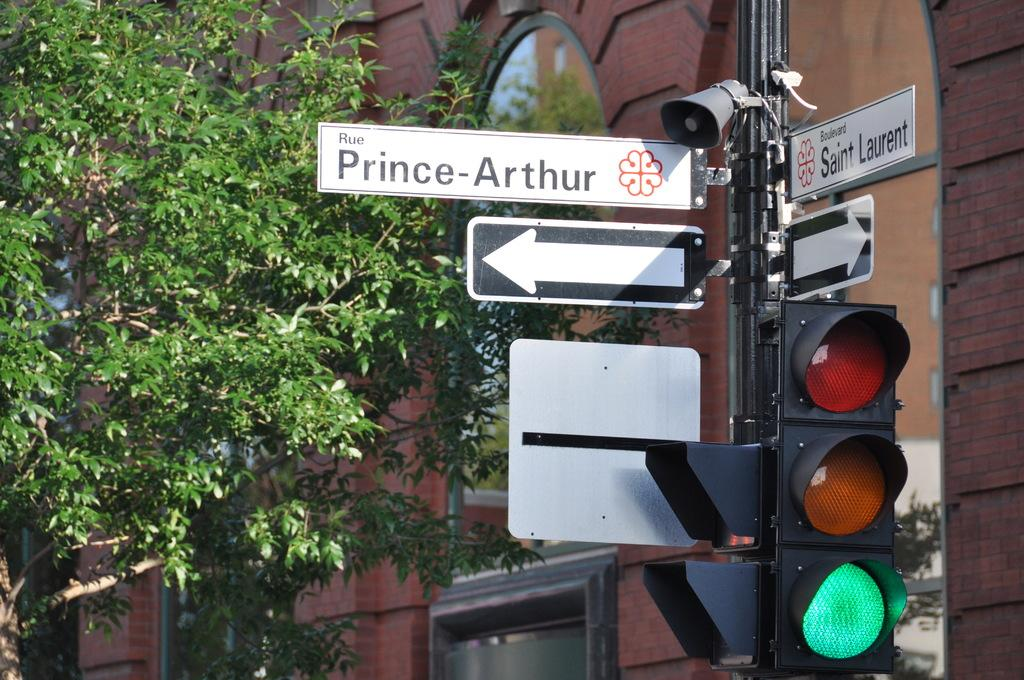<image>
Render a clear and concise summary of the photo. A white street sign for Rue Prince-Arthur is above a one way sign. 